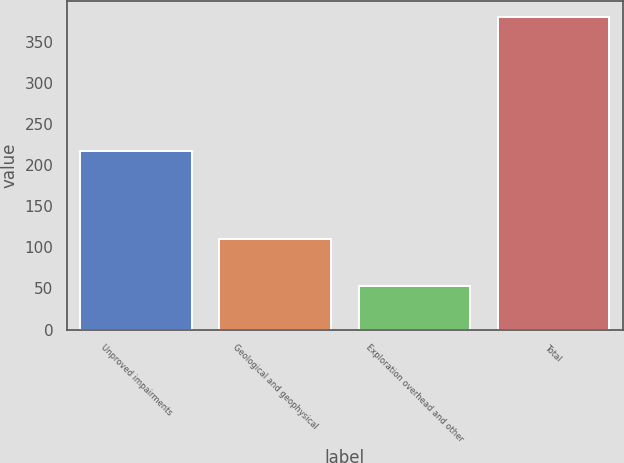<chart> <loc_0><loc_0><loc_500><loc_500><bar_chart><fcel>Unproved impairments<fcel>Geological and geophysical<fcel>Exploration overhead and other<fcel>Total<nl><fcel>217<fcel>110<fcel>53<fcel>380<nl></chart> 